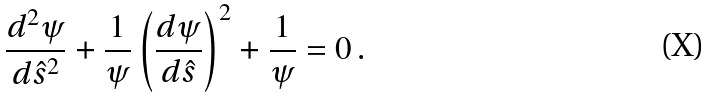Convert formula to latex. <formula><loc_0><loc_0><loc_500><loc_500>\frac { d ^ { 2 } \psi } { d \hat { s } ^ { 2 } } + \frac { 1 } { \psi } \left ( \frac { d \psi } { d \hat { s } } \right ) ^ { 2 } + \frac { 1 } { \psi } = 0 \, .</formula> 